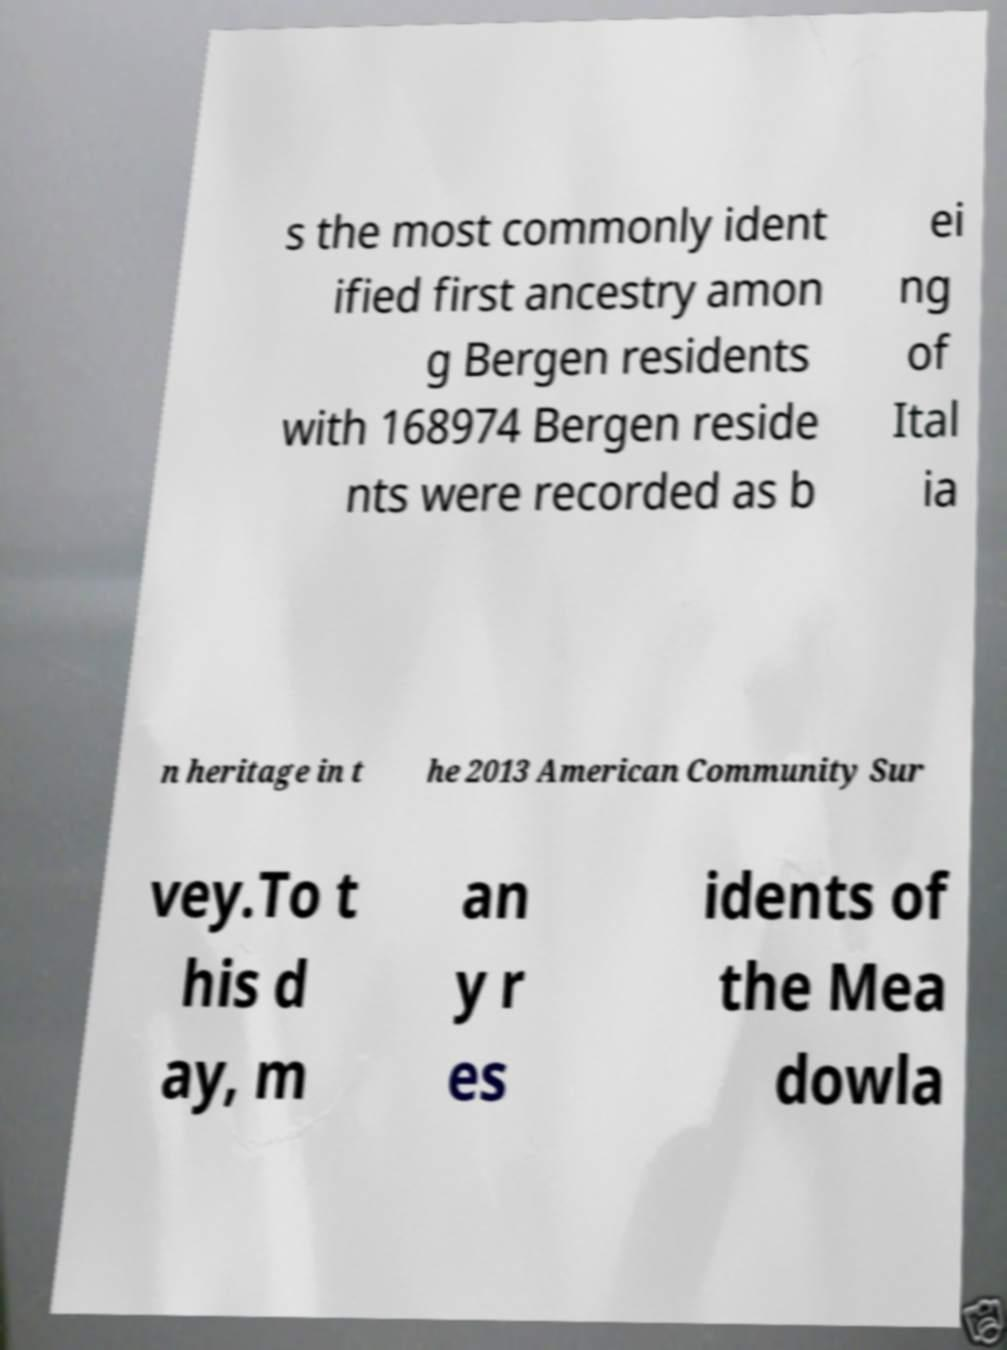Can you accurately transcribe the text from the provided image for me? s the most commonly ident ified first ancestry amon g Bergen residents with 168974 Bergen reside nts were recorded as b ei ng of Ital ia n heritage in t he 2013 American Community Sur vey.To t his d ay, m an y r es idents of the Mea dowla 